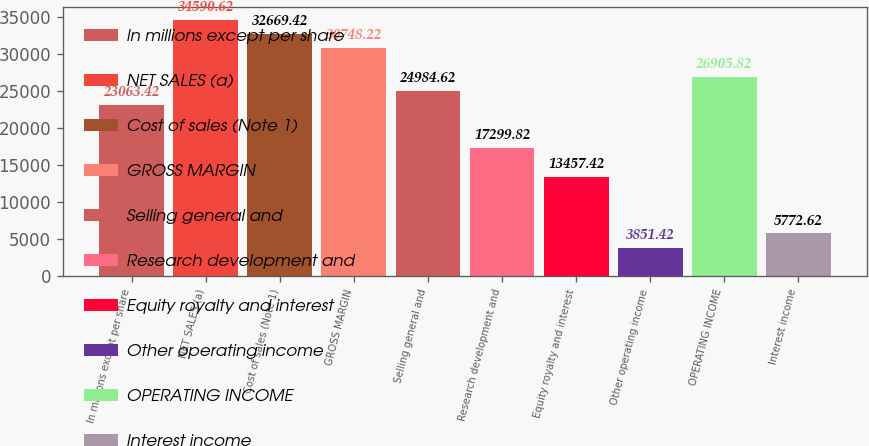<chart> <loc_0><loc_0><loc_500><loc_500><bar_chart><fcel>In millions except per share<fcel>NET SALES (a)<fcel>Cost of sales (Note 1)<fcel>GROSS MARGIN<fcel>Selling general and<fcel>Research development and<fcel>Equity royalty and interest<fcel>Other operating income<fcel>OPERATING INCOME<fcel>Interest income<nl><fcel>23063.4<fcel>34590.6<fcel>32669.4<fcel>30748.2<fcel>24984.6<fcel>17299.8<fcel>13457.4<fcel>3851.42<fcel>26905.8<fcel>5772.62<nl></chart> 